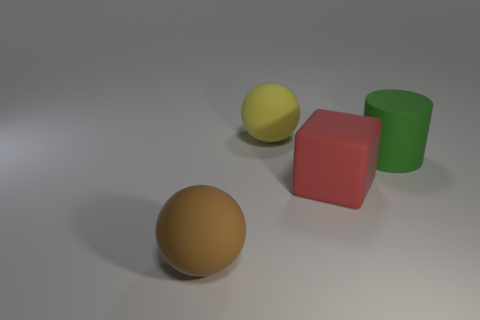Add 1 big objects. How many objects exist? 5 Subtract 1 brown spheres. How many objects are left? 3 Subtract all cubes. How many objects are left? 3 Subtract 1 cylinders. How many cylinders are left? 0 Subtract all blue blocks. Subtract all red spheres. How many blocks are left? 1 Subtract all blue cubes. How many brown cylinders are left? 0 Subtract all large blue matte objects. Subtract all cubes. How many objects are left? 3 Add 3 brown objects. How many brown objects are left? 4 Add 3 small blue blocks. How many small blue blocks exist? 3 